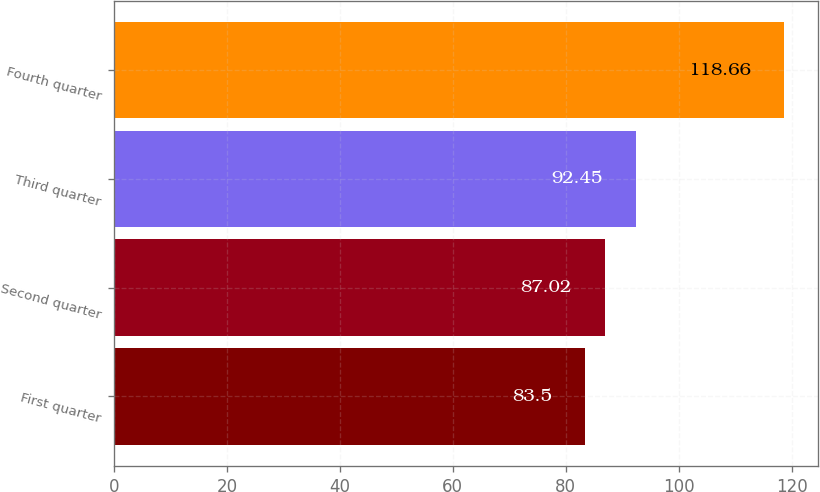<chart> <loc_0><loc_0><loc_500><loc_500><bar_chart><fcel>First quarter<fcel>Second quarter<fcel>Third quarter<fcel>Fourth quarter<nl><fcel>83.5<fcel>87.02<fcel>92.45<fcel>118.66<nl></chart> 